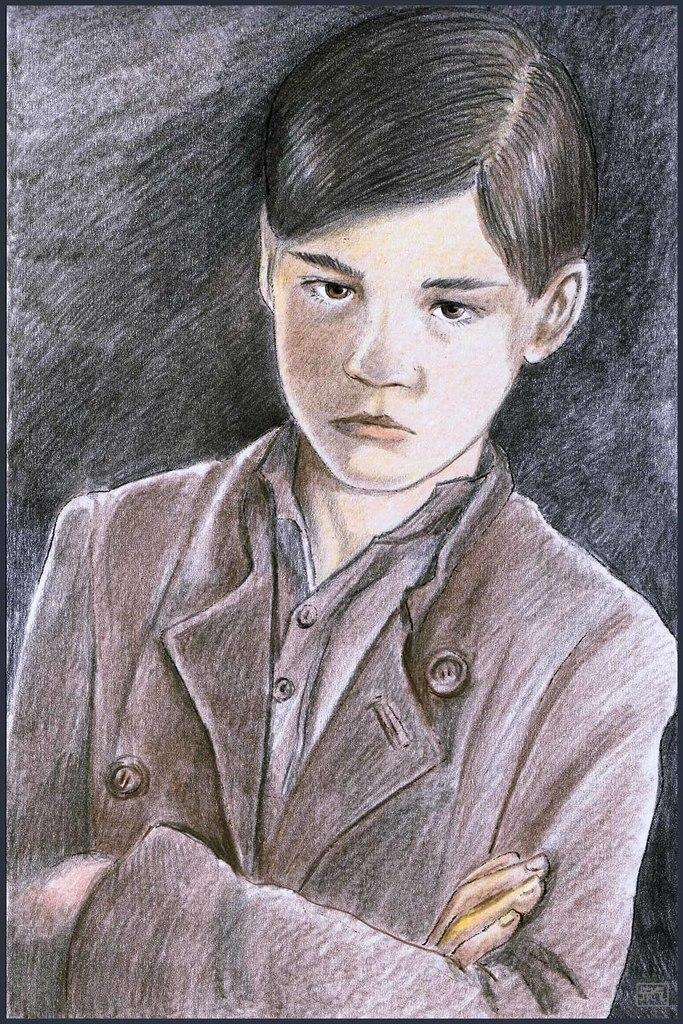What is depicted in the image? There is a drawing of a boy in the image. What is the boy wearing in the drawing? The boy is wearing a jacket in the drawing. Where is the nest located in the image? There is no nest present in the image; it is a drawing of a boy wearing a jacket. What type of ice can be seen melting in the image? There is no ice present in the image; it is a drawing of a boy wearing a jacket. 